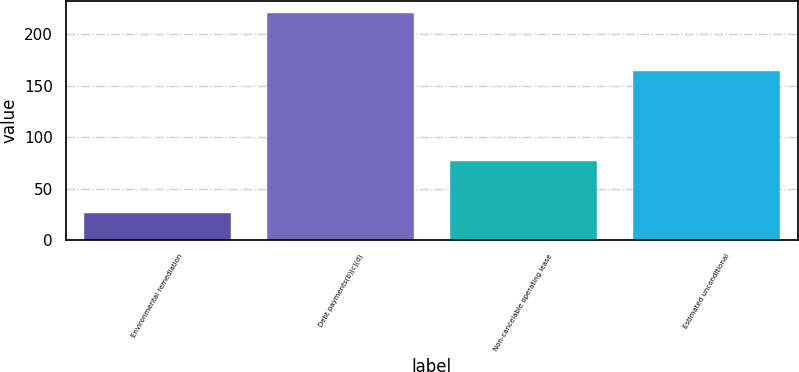Convert chart. <chart><loc_0><loc_0><loc_500><loc_500><bar_chart><fcel>Environmental remediation<fcel>Debt payments(b)(c)(d)<fcel>Non-cancelable operating lease<fcel>Estimated unconditional<nl><fcel>26<fcel>221<fcel>77<fcel>164<nl></chart> 